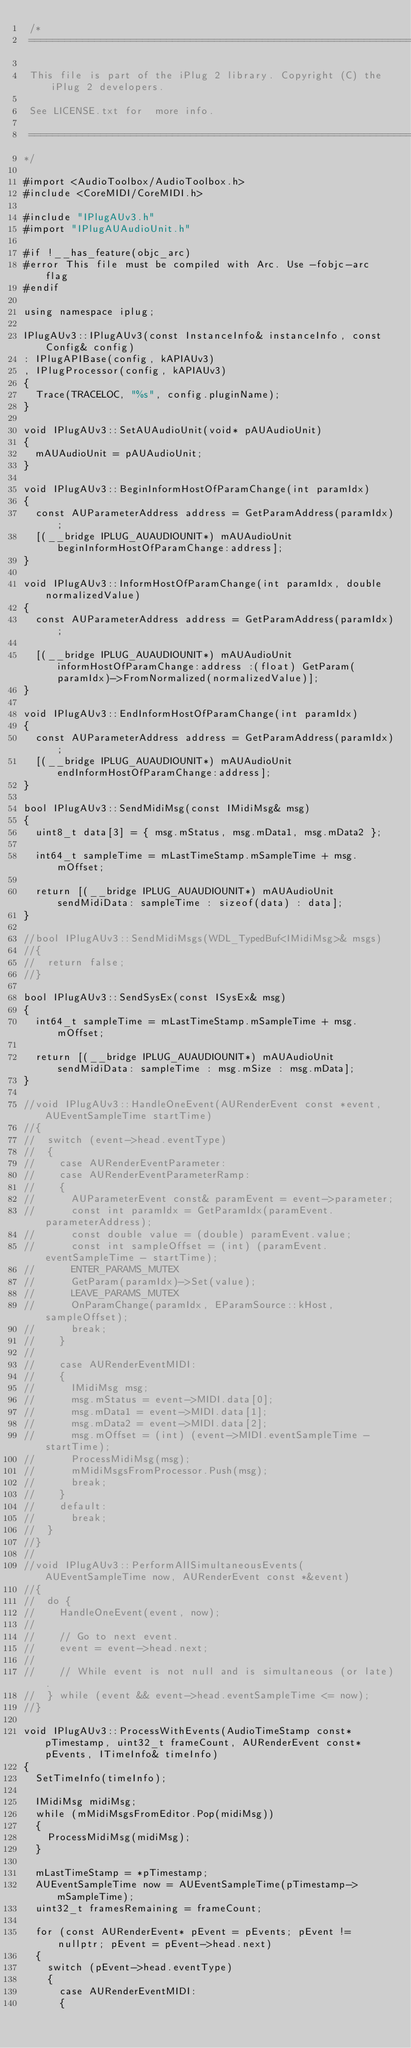Convert code to text. <code><loc_0><loc_0><loc_500><loc_500><_ObjectiveC_> /*
 ==============================================================================
 
 This file is part of the iPlug 2 library. Copyright (C) the iPlug 2 developers. 
 
 See LICENSE.txt for  more info.
 
 ==============================================================================
*/

#import <AudioToolbox/AudioToolbox.h>
#include <CoreMIDI/CoreMIDI.h>

#include "IPlugAUv3.h"
#import "IPlugAUAudioUnit.h"

#if !__has_feature(objc_arc)
#error This file must be compiled with Arc. Use -fobjc-arc flag
#endif

using namespace iplug;

IPlugAUv3::IPlugAUv3(const InstanceInfo& instanceInfo, const Config& config)
: IPlugAPIBase(config, kAPIAUv3)
, IPlugProcessor(config, kAPIAUv3)
{
  Trace(TRACELOC, "%s", config.pluginName);
}

void IPlugAUv3::SetAUAudioUnit(void* pAUAudioUnit)
{
  mAUAudioUnit = pAUAudioUnit;
}

void IPlugAUv3::BeginInformHostOfParamChange(int paramIdx)
{
  const AUParameterAddress address = GetParamAddress(paramIdx);
  [(__bridge IPLUG_AUAUDIOUNIT*) mAUAudioUnit beginInformHostOfParamChange:address];
}

void IPlugAUv3::InformHostOfParamChange(int paramIdx, double normalizedValue)
{
  const AUParameterAddress address = GetParamAddress(paramIdx);

  [(__bridge IPLUG_AUAUDIOUNIT*) mAUAudioUnit informHostOfParamChange:address :(float) GetParam(paramIdx)->FromNormalized(normalizedValue)];
}

void IPlugAUv3::EndInformHostOfParamChange(int paramIdx)
{
  const AUParameterAddress address = GetParamAddress(paramIdx);
  [(__bridge IPLUG_AUAUDIOUNIT*) mAUAudioUnit endInformHostOfParamChange:address];
}

bool IPlugAUv3::SendMidiMsg(const IMidiMsg& msg)
{
  uint8_t data[3] = { msg.mStatus, msg.mData1, msg.mData2 };
  
  int64_t sampleTime = mLastTimeStamp.mSampleTime + msg.mOffset;
  
  return [(__bridge IPLUG_AUAUDIOUNIT*) mAUAudioUnit sendMidiData: sampleTime : sizeof(data) : data];
}

//bool IPlugAUv3::SendMidiMsgs(WDL_TypedBuf<IMidiMsg>& msgs)
//{
//  return false;
//}

bool IPlugAUv3::SendSysEx(const ISysEx& msg)
{
  int64_t sampleTime = mLastTimeStamp.mSampleTime + msg.mOffset;

  return [(__bridge IPLUG_AUAUDIOUNIT*) mAUAudioUnit sendMidiData: sampleTime : msg.mSize : msg.mData];
}

//void IPlugAUv3::HandleOneEvent(AURenderEvent const *event, AUEventSampleTime startTime)
//{
//  switch (event->head.eventType)
//  {
//    case AURenderEventParameter:
//    case AURenderEventParameterRamp:
//    {
//      AUParameterEvent const& paramEvent = event->parameter;
//      const int paramIdx = GetParamIdx(paramEvent.parameterAddress);
//      const double value = (double) paramEvent.value;
//      const int sampleOffset = (int) (paramEvent.eventSampleTime - startTime);
//      ENTER_PARAMS_MUTEX
//      GetParam(paramIdx)->Set(value);
//      LEAVE_PARAMS_MUTEX
//      OnParamChange(paramIdx, EParamSource::kHost, sampleOffset);
//      break;
//    }
//
//    case AURenderEventMIDI:
//    {
//      IMidiMsg msg;
//      msg.mStatus = event->MIDI.data[0];
//      msg.mData1 = event->MIDI.data[1];
//      msg.mData2 = event->MIDI.data[2];
//      msg.mOffset = (int) (event->MIDI.eventSampleTime - startTime);
//      ProcessMidiMsg(msg);
//      mMidiMsgsFromProcessor.Push(msg);
//      break;
//    }
//    default:
//      break;
//  }
//}
//
//void IPlugAUv3::PerformAllSimultaneousEvents(AUEventSampleTime now, AURenderEvent const *&event)
//{
//  do {
//    HandleOneEvent(event, now);
//
//    // Go to next event.
//    event = event->head.next;
//
//    // While event is not null and is simultaneous (or late).
//  } while (event && event->head.eventSampleTime <= now);
//}

void IPlugAUv3::ProcessWithEvents(AudioTimeStamp const* pTimestamp, uint32_t frameCount, AURenderEvent const* pEvents, ITimeInfo& timeInfo)
{
  SetTimeInfo(timeInfo);
  
  IMidiMsg midiMsg;
  while (mMidiMsgsFromEditor.Pop(midiMsg))
  {
    ProcessMidiMsg(midiMsg);
  }
  
  mLastTimeStamp = *pTimestamp;
  AUEventSampleTime now = AUEventSampleTime(pTimestamp->mSampleTime);
  uint32_t framesRemaining = frameCount;
  
  for (const AURenderEvent* pEvent = pEvents; pEvent != nullptr; pEvent = pEvent->head.next)
  {
    switch (pEvent->head.eventType)
    {
      case AURenderEventMIDI:
      {</code> 